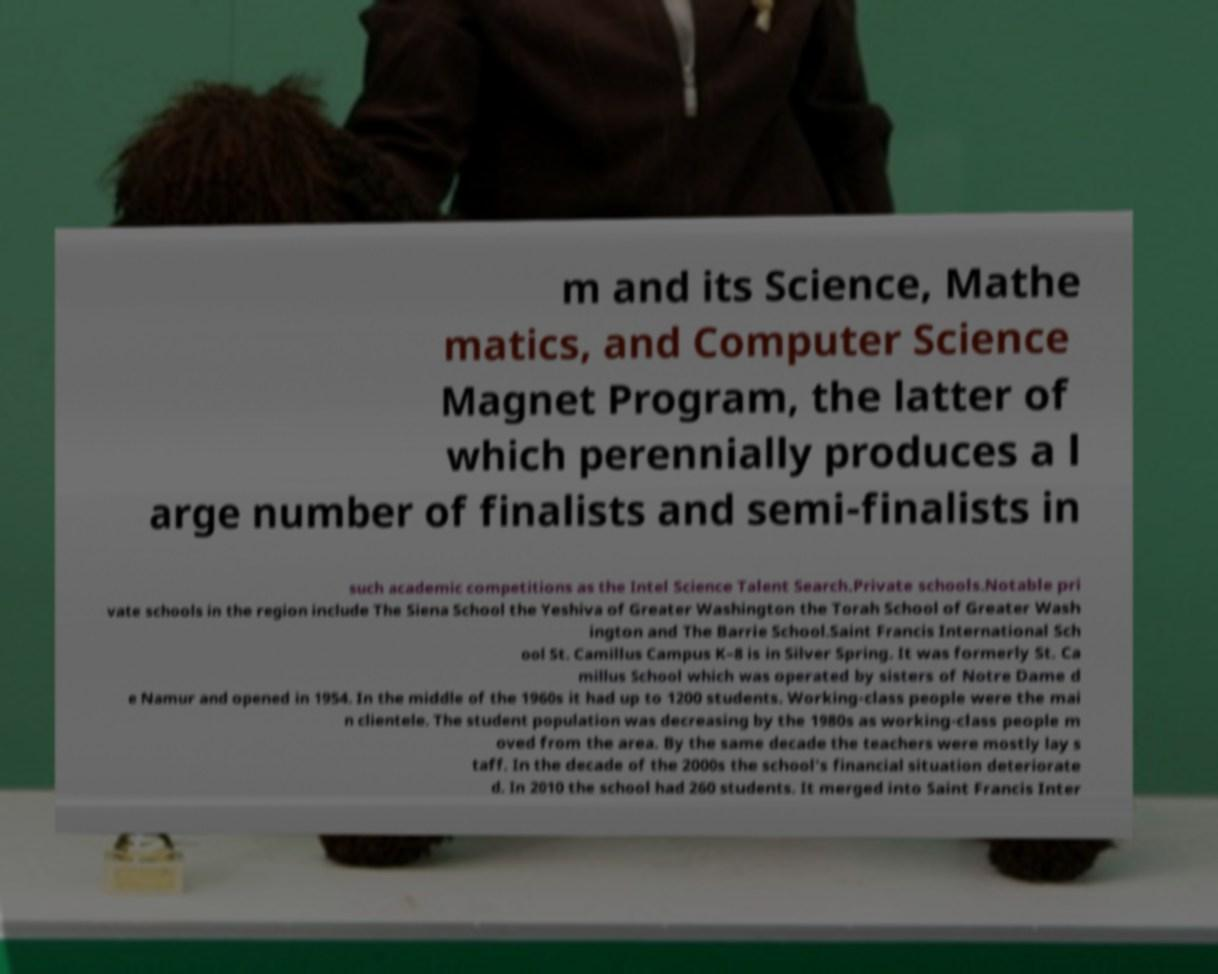What messages or text are displayed in this image? I need them in a readable, typed format. m and its Science, Mathe matics, and Computer Science Magnet Program, the latter of which perennially produces a l arge number of finalists and semi-finalists in such academic competitions as the Intel Science Talent Search.Private schools.Notable pri vate schools in the region include The Siena School the Yeshiva of Greater Washington the Torah School of Greater Wash ington and The Barrie School.Saint Francis International Sch ool St. Camillus Campus K–8 is in Silver Spring. It was formerly St. Ca millus School which was operated by sisters of Notre Dame d e Namur and opened in 1954. In the middle of the 1960s it had up to 1200 students. Working-class people were the mai n clientele. The student population was decreasing by the 1980s as working-class people m oved from the area. By the same decade the teachers were mostly lay s taff. In the decade of the 2000s the school's financial situation deteriorate d. In 2010 the school had 260 students. It merged into Saint Francis Inter 